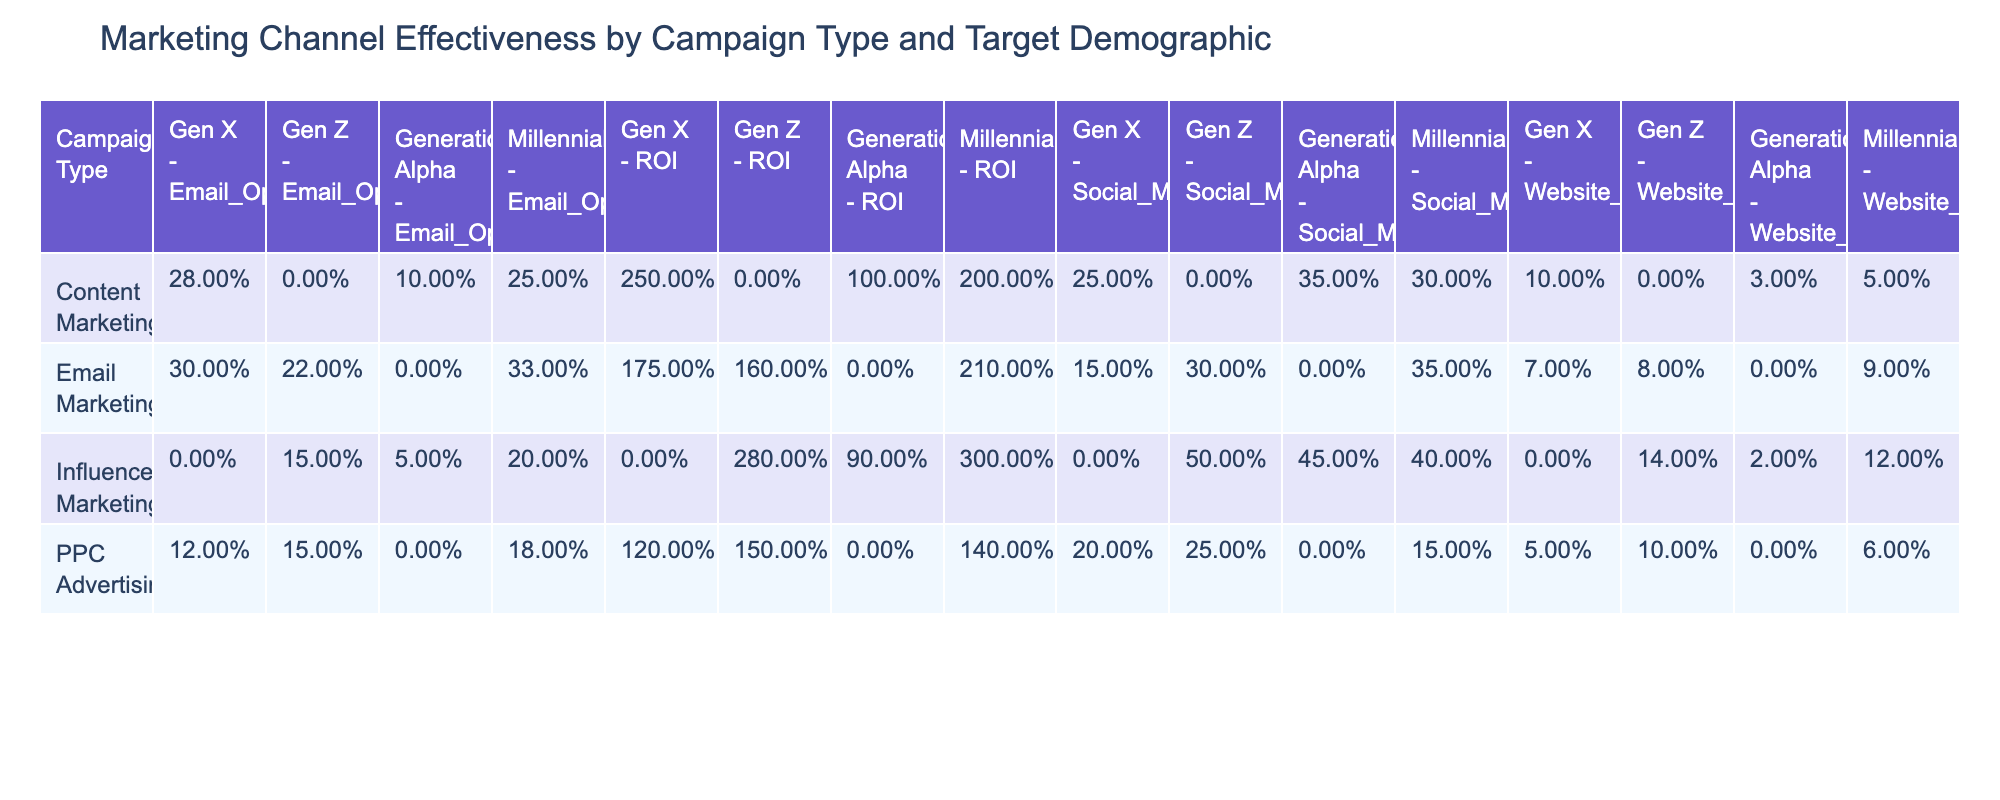What is the Email Open Rate for Influencer Marketing targeting Generation Alpha? The table displays the Email Open Rate for different combinations of Campaign Type and Target Demographic. For Influencer Marketing and Generation Alpha, the Email Open Rate value is listed as 5%.
Answer: 5% Which campaign type has the highest ROI for Millennials? By reviewing the ROI values in the table for the Millennials demographic across different campaign types, Influencer Marketing has the highest ROI of 300%.
Answer: 300% What is the average Website Conversion Rate across all campaign types for Gen X? To calculate the average Website Conversion Rate for Gen X, we identify the values from the table: Email Marketing (7%), PPC Advertising (5%), and Content Marketing (10%). The sum is (7 + 5 + 10) = 22, and there are 3 data points, resulting in an average of 22/3 = 7.33%.
Answer: 7.33% Does Email Marketing have a better Email Open Rate than PPC Advertising for Gen Z? For Gen Z, Email Marketing has an Email Open Rate of 22%, while PPC Advertising has 15%. Since 22% is greater than 15%, the answer is yes.
Answer: Yes What demographic has the highest Social Media Engagement rate in Content Marketing? Looking at the Social Media Engagement rates for Content Marketing, we see Millennials at 30%, Generation Alpha at 35%, and Gen X at 25%. The highest rate is 35% for Generation Alpha.
Answer: Generation Alpha What is the difference in ROI between Influencer Marketing for Millennials and Influencer Marketing for Gen Z? The ROI for Influencer Marketing for Millennials is 300% and for Gen Z is 280%. To find the difference, we subtract 280% from 300%, resulting in a difference of 20%.
Answer: 20% Is the Website Conversion Rate for Email Marketing higher for Millennials than for Gen X? The table shows that the Website Conversion Rate for Email Marketing targeting Millennials is 9%, whereas for Gen X it is 7%. Since 9% is greater than 7%, the answer is yes.
Answer: Yes What is the total Email Open Rate across all campaign types for Generation Alpha? For Generation Alpha, the Email Open Rates from the table are 10% (Content Marketing) and 5% (Influencer Marketing). The total Email Open Rate is calculated by adding these values: 10% + 5% = 15%.
Answer: 15% 